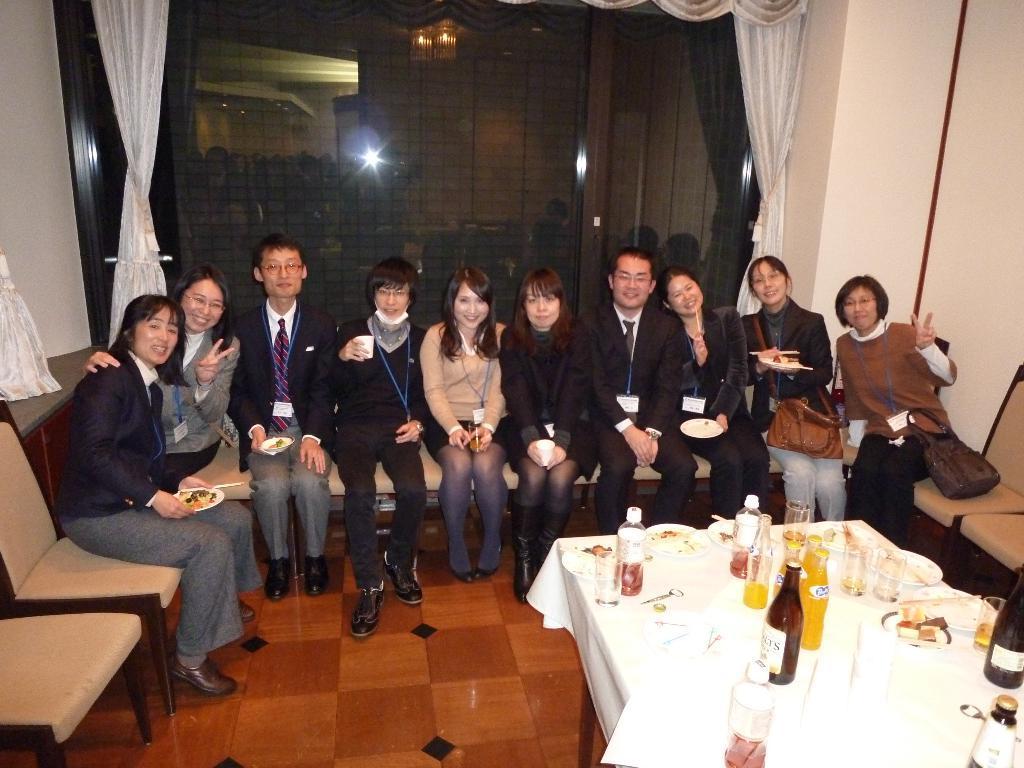Could you give a brief overview of what you see in this image? This picture is clicked in a room. There are ten people sitting on sofa. Behind them, we see a white pillar and a window glass. We even see white curtain. In front of them, we see a table on which glass bottle, water bottle, cold drink bottle, plate containing food and spoon are placed on it. 